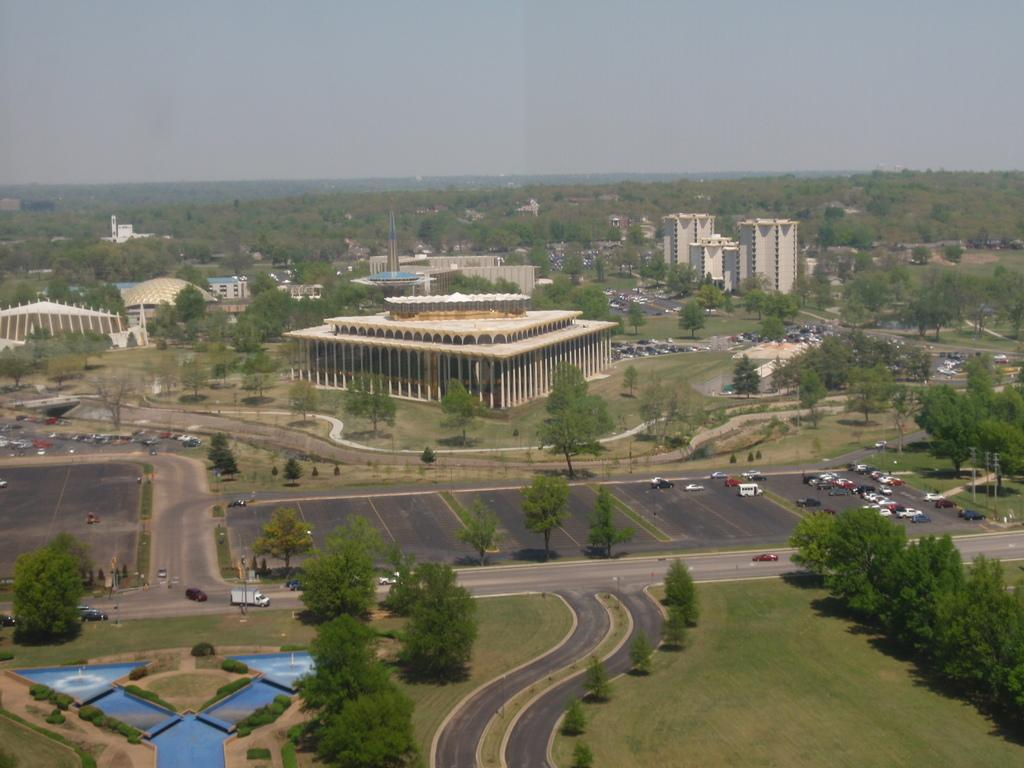What type of view is shown in the image? The image is an aerial view. What structures can be seen in the image? There are buildings and towers in the image. What type of vegetation is present in the image? There are trees in the image. What other objects can be seen in the image? There are poles and vehicles on the road in the image. What natural element is visible in the image? There is water visible in the image. What is visible at the top of the image? The sky is visible at the top of the image. What type of leather is being used to make the yarn in the image? There is no leather or yarn present in the image. The image features an aerial view of buildings, towers, trees, poles, vehicles, water, and the sky. 